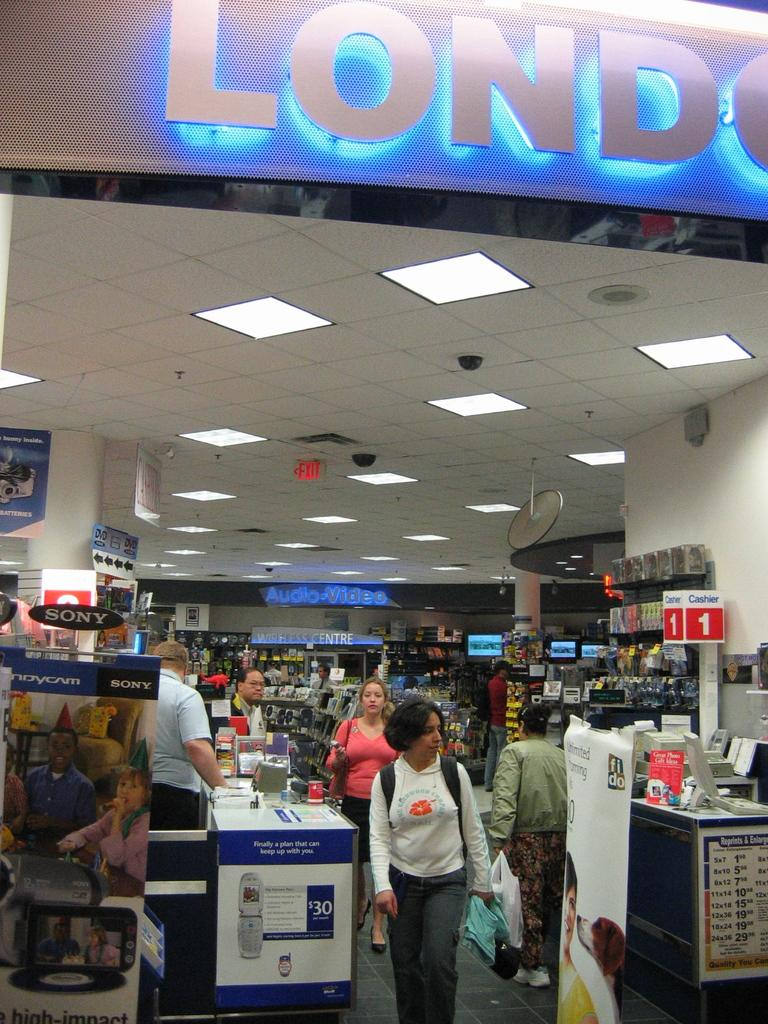Provide a one-sentence caption for the provided image. People shopping in a store, with the words Audio Video lit up. 